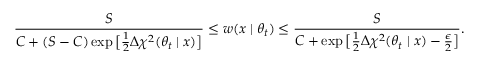<formula> <loc_0><loc_0><loc_500><loc_500>\frac { S } { C + ( S - C ) \exp \left [ \frac { 1 } { 2 } \Delta \chi ^ { 2 } ( \theta _ { t } | x ) \right ] } \leq w ( x | \theta _ { t } ) \leq \frac { S } { C + \exp \left [ \frac { 1 } { 2 } \Delta \chi ^ { 2 } ( \theta _ { t } | x ) - \frac { \epsilon } { 2 } \right ] } .</formula> 